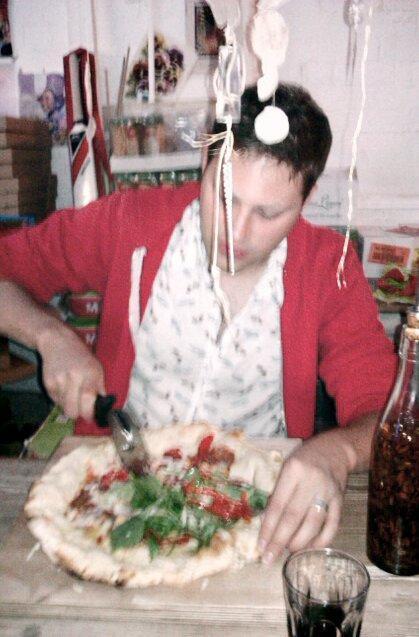Is the given caption "The person is touching the pizza." fitting for the image?
Answer yes or no. Yes. 